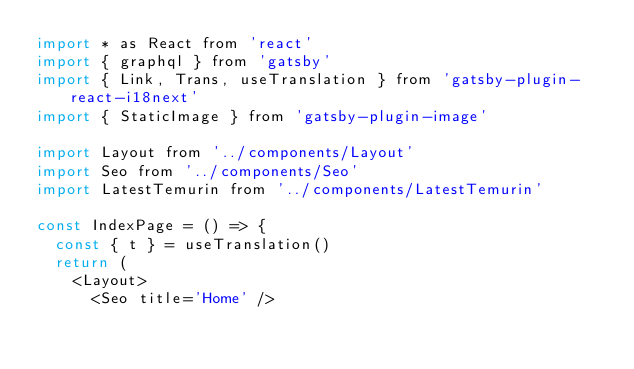<code> <loc_0><loc_0><loc_500><loc_500><_JavaScript_>import * as React from 'react'
import { graphql } from 'gatsby'
import { Link, Trans, useTranslation } from 'gatsby-plugin-react-i18next'
import { StaticImage } from 'gatsby-plugin-image'

import Layout from '../components/Layout'
import Seo from '../components/Seo'
import LatestTemurin from '../components/LatestTemurin'

const IndexPage = () => {
  const { t } = useTranslation()
  return (
    <Layout>
      <Seo title='Home' /></code> 